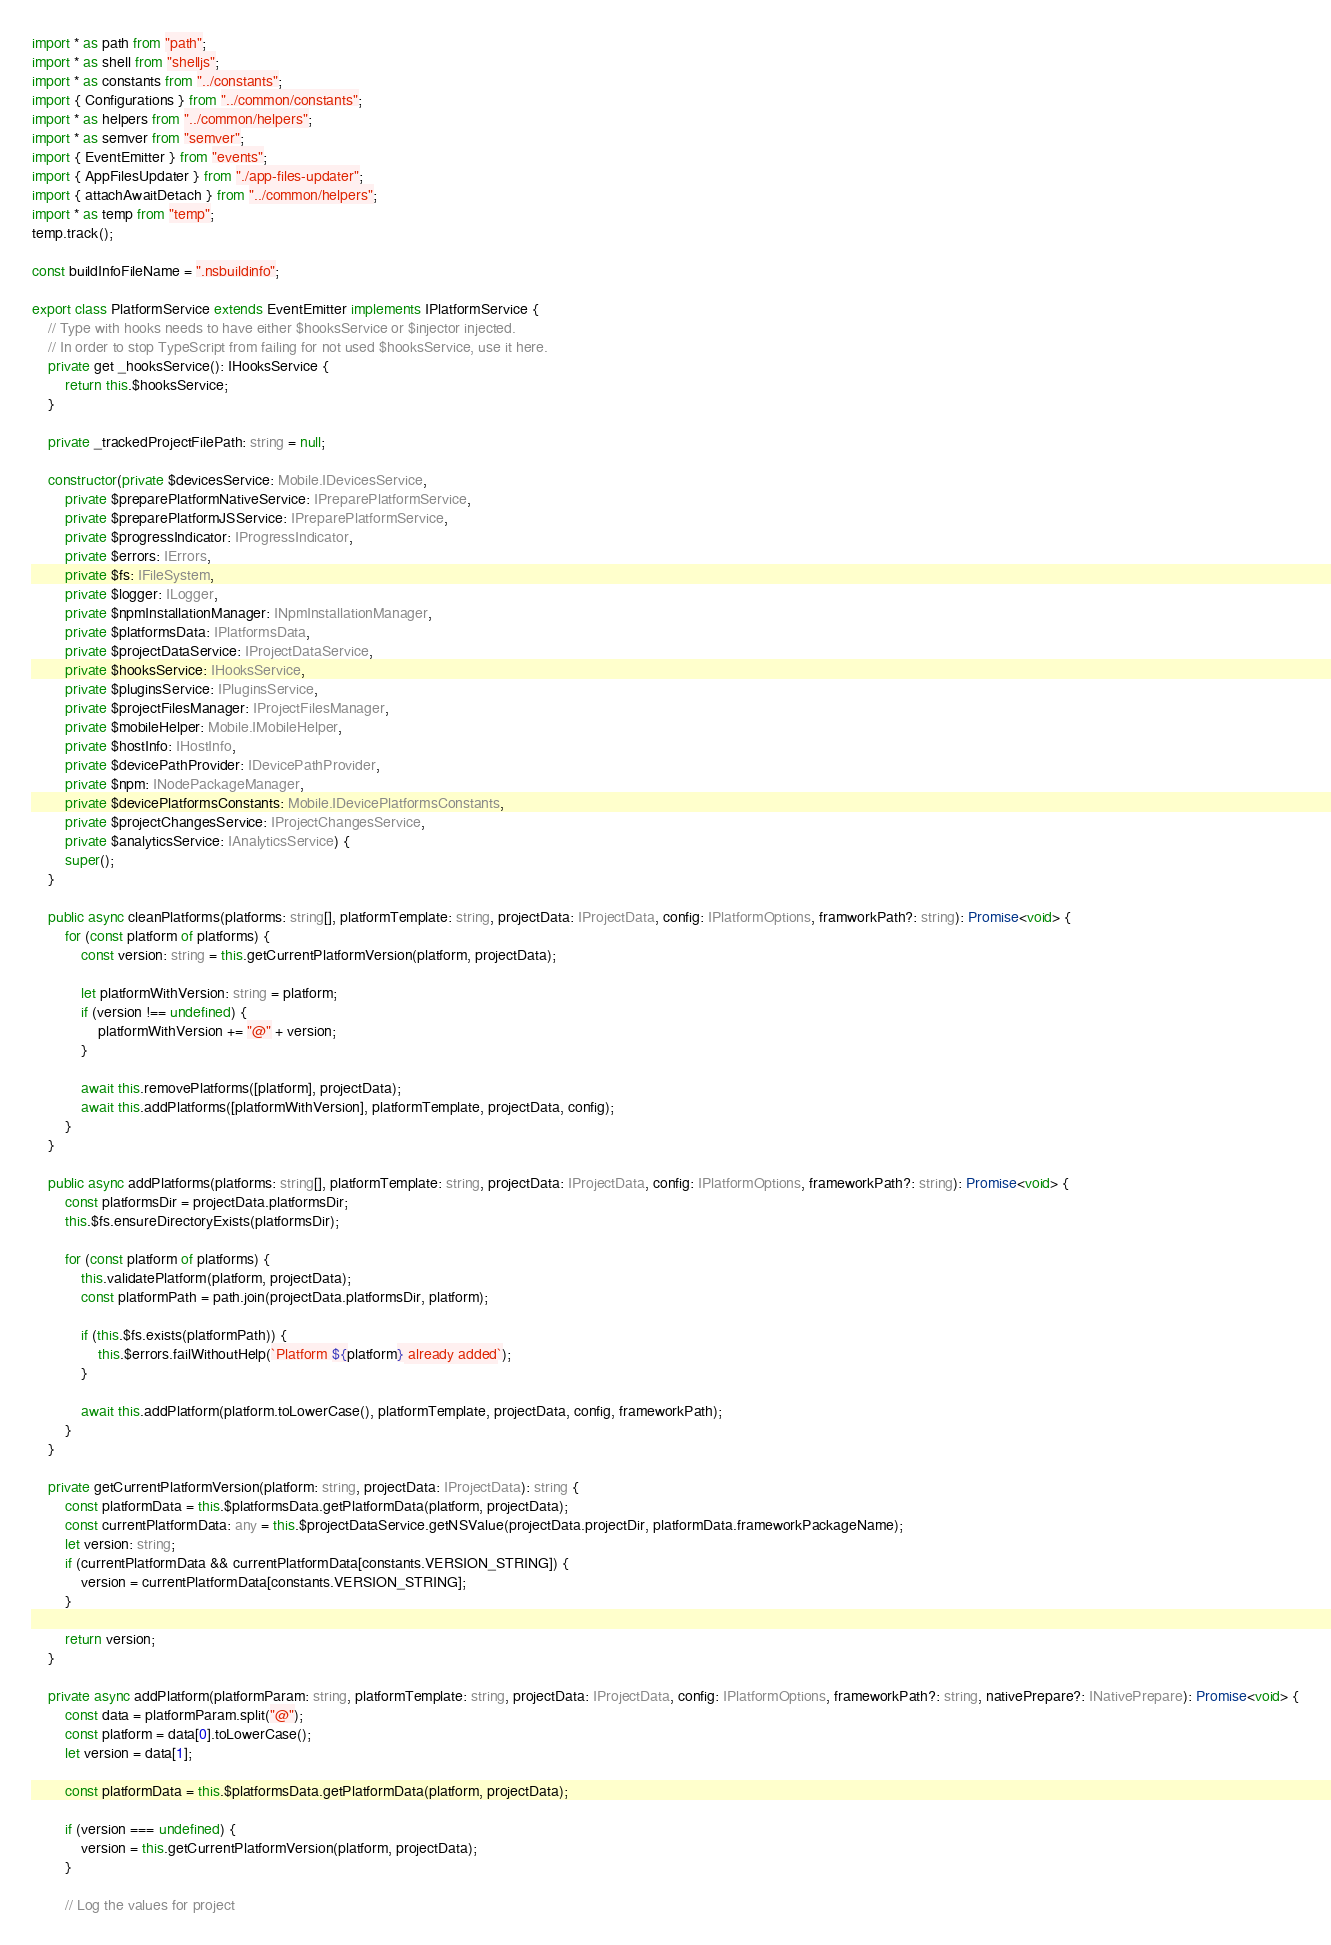<code> <loc_0><loc_0><loc_500><loc_500><_TypeScript_>import * as path from "path";
import * as shell from "shelljs";
import * as constants from "../constants";
import { Configurations } from "../common/constants";
import * as helpers from "../common/helpers";
import * as semver from "semver";
import { EventEmitter } from "events";
import { AppFilesUpdater } from "./app-files-updater";
import { attachAwaitDetach } from "../common/helpers";
import * as temp from "temp";
temp.track();

const buildInfoFileName = ".nsbuildinfo";

export class PlatformService extends EventEmitter implements IPlatformService {
	// Type with hooks needs to have either $hooksService or $injector injected.
	// In order to stop TypeScript from failing for not used $hooksService, use it here.
	private get _hooksService(): IHooksService {
		return this.$hooksService;
	}

	private _trackedProjectFilePath: string = null;

	constructor(private $devicesService: Mobile.IDevicesService,
		private $preparePlatformNativeService: IPreparePlatformService,
		private $preparePlatformJSService: IPreparePlatformService,
		private $progressIndicator: IProgressIndicator,
		private $errors: IErrors,
		private $fs: IFileSystem,
		private $logger: ILogger,
		private $npmInstallationManager: INpmInstallationManager,
		private $platformsData: IPlatformsData,
		private $projectDataService: IProjectDataService,
		private $hooksService: IHooksService,
		private $pluginsService: IPluginsService,
		private $projectFilesManager: IProjectFilesManager,
		private $mobileHelper: Mobile.IMobileHelper,
		private $hostInfo: IHostInfo,
		private $devicePathProvider: IDevicePathProvider,
		private $npm: INodePackageManager,
		private $devicePlatformsConstants: Mobile.IDevicePlatformsConstants,
		private $projectChangesService: IProjectChangesService,
		private $analyticsService: IAnalyticsService) {
		super();
	}

	public async cleanPlatforms(platforms: string[], platformTemplate: string, projectData: IProjectData, config: IPlatformOptions, framworkPath?: string): Promise<void> {
		for (const platform of platforms) {
			const version: string = this.getCurrentPlatformVersion(platform, projectData);

			let platformWithVersion: string = platform;
			if (version !== undefined) {
				platformWithVersion += "@" + version;
			}

			await this.removePlatforms([platform], projectData);
			await this.addPlatforms([platformWithVersion], platformTemplate, projectData, config);
		}
	}

	public async addPlatforms(platforms: string[], platformTemplate: string, projectData: IProjectData, config: IPlatformOptions, frameworkPath?: string): Promise<void> {
		const platformsDir = projectData.platformsDir;
		this.$fs.ensureDirectoryExists(platformsDir);

		for (const platform of platforms) {
			this.validatePlatform(platform, projectData);
			const platformPath = path.join(projectData.platformsDir, platform);

			if (this.$fs.exists(platformPath)) {
				this.$errors.failWithoutHelp(`Platform ${platform} already added`);
			}

			await this.addPlatform(platform.toLowerCase(), platformTemplate, projectData, config, frameworkPath);
		}
	}

	private getCurrentPlatformVersion(platform: string, projectData: IProjectData): string {
		const platformData = this.$platformsData.getPlatformData(platform, projectData);
		const currentPlatformData: any = this.$projectDataService.getNSValue(projectData.projectDir, platformData.frameworkPackageName);
		let version: string;
		if (currentPlatformData && currentPlatformData[constants.VERSION_STRING]) {
			version = currentPlatformData[constants.VERSION_STRING];
		}

		return version;
	}

	private async addPlatform(platformParam: string, platformTemplate: string, projectData: IProjectData, config: IPlatformOptions, frameworkPath?: string, nativePrepare?: INativePrepare): Promise<void> {
		const data = platformParam.split("@");
		const platform = data[0].toLowerCase();
		let version = data[1];

		const platformData = this.$platformsData.getPlatformData(platform, projectData);

		if (version === undefined) {
			version = this.getCurrentPlatformVersion(platform, projectData);
		}

		// Log the values for project</code> 